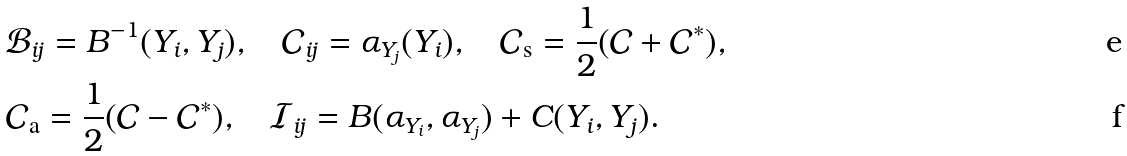<formula> <loc_0><loc_0><loc_500><loc_500>& \mathcal { B } _ { i j } = B ^ { - 1 } ( Y _ { i } , Y _ { j } ) , \quad \mathcal { C } _ { i j } = \alpha _ { Y _ { j } } ( Y _ { i } ) , \quad \mathcal { C } _ { \mathrm s } = \frac { 1 } { 2 } ( \mathcal { C } + \mathcal { C } ^ { * } ) , \\ & \mathcal { C } _ { \mathrm a } = \frac { 1 } { 2 } ( \mathcal { C } - \mathcal { C } ^ { * } ) , \quad \mathcal { I } _ { i j } = B ( \alpha _ { Y _ { i } } , \alpha _ { Y _ { j } } ) + C ( Y _ { i } , Y _ { j } ) .</formula> 